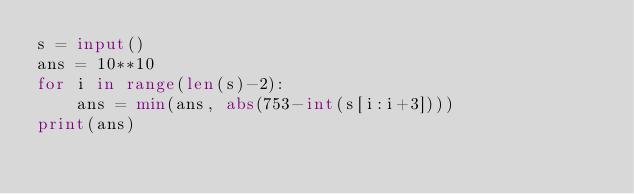Convert code to text. <code><loc_0><loc_0><loc_500><loc_500><_Python_>s = input()
ans = 10**10
for i in range(len(s)-2):
    ans = min(ans, abs(753-int(s[i:i+3])))
print(ans)</code> 